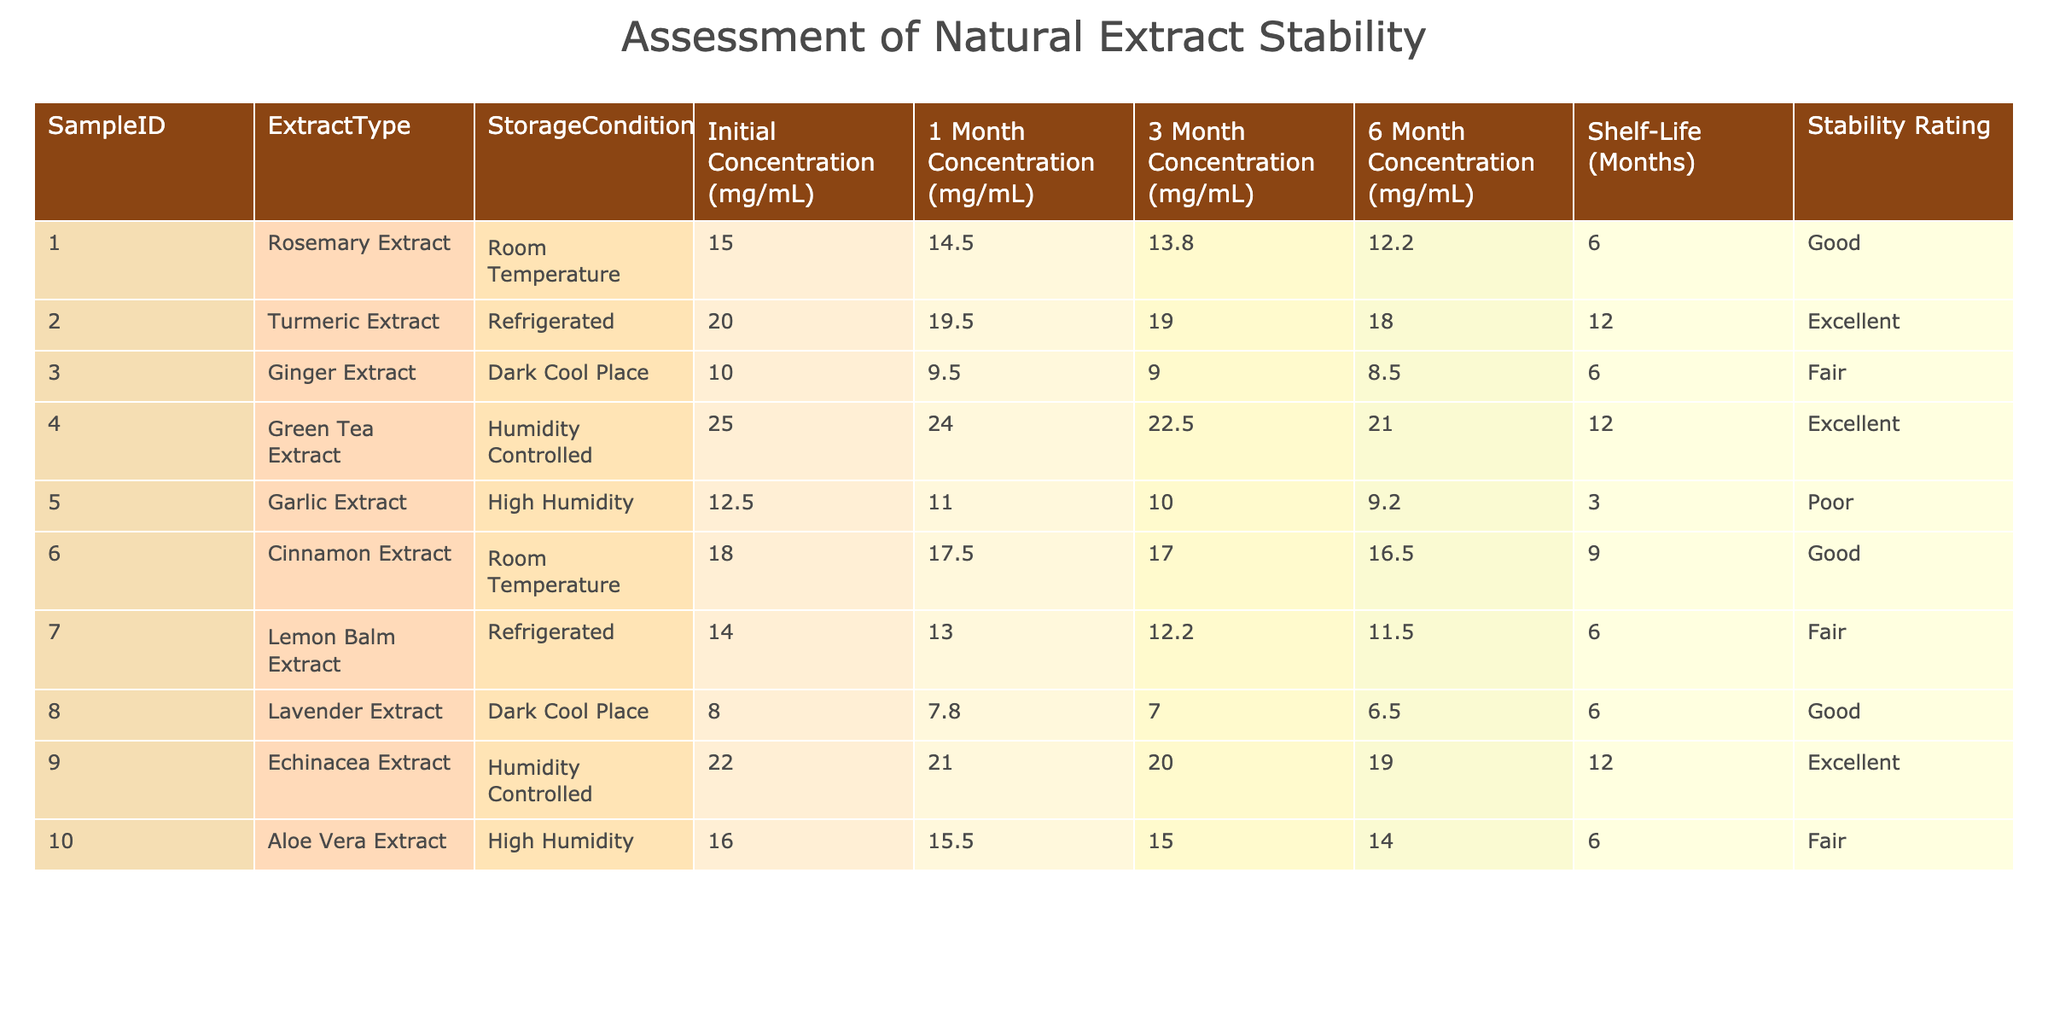What is the initial concentration of the Turmeric Extract? The table lists the Initial Concentration for Turmeric Extract under the column for Initial Concentration. The value provided is 20.0 mg/mL.
Answer: 20.0 mg/mL How many extracts have a Shelf-Life of 12 months? By examining the Shelf-Life column, the extracts with a shelf-life of 12 months are Turmeric Extract, Green Tea Extract, and Echinacea Extract. Counting these yields a total of 3.
Answer: 3 What is the stability rating of the Garlic Extract? Looking at the Stability Rating column for the Garlic Extract, the value is Poor, which indicates its lower stability compared to others.
Answer: Poor Which extract had the highest initial concentration? To find the highest initial concentration, we compare the Initial Concentration values for all extracts. The Green Tea Extract has the highest value at 25.0 mg/mL.
Answer: 25.0 mg/mL What is the difference in 6-month concentrations between the Rosemary Extract and Ginger Extract? For Rosemary Extract, the 6-month concentration is 12.2 mg/mL, while for Ginger Extract, it's 8.5 mg/mL. The difference is calculated as 12.2 - 8.5 = 3.7 mg/mL.
Answer: 3.7 mg/mL Is the Cinnamon Extract stored at Room Temperature considered to be excellent in stability? According to the Stability Rating column, the Cinnamon Extract has a rating of Good, which means it is not considered excellent.
Answer: No Which extract had the most significant decrease in concentration after 6 months? We need to examine the 6-month concentrations and initial concentrations for all extracts. Garlic Extract starts at 12.5 mg/mL and reduces to 9.2 mg/mL, a decrease of 3.3 mg/mL. Comparing others, it shows that Garlic Extract had the largest drop.
Answer: Garlic Extract How does the stability rating correlate with the shelf-life for extracts that are stored in High Humidity conditions? Looking at the data for Aloe Vera Extract and Garlic Extract, Aloe Vera has a Fair rating with a 6-month shelf-life and Garlic has a Poor rating with a 3-month shelf-life. This suggests that lower stability ratings correspond with shorter shelf-lives in High Humidity conditions.
Answer: Yes What is the average initial concentration of extracts with an 'Excellent' stability rating? The extracts with excellent ratings are Turmeric, Green Tea, and Echinacea. Their initial concentrations are 20.0 mg/mL, 25.0 mg/mL, and 22.0 mg/mL, respectively. The average is calculated as (20.0 + 25.0 + 22.0) / 3 = 22.33 mg/mL.
Answer: 22.33 mg/mL 